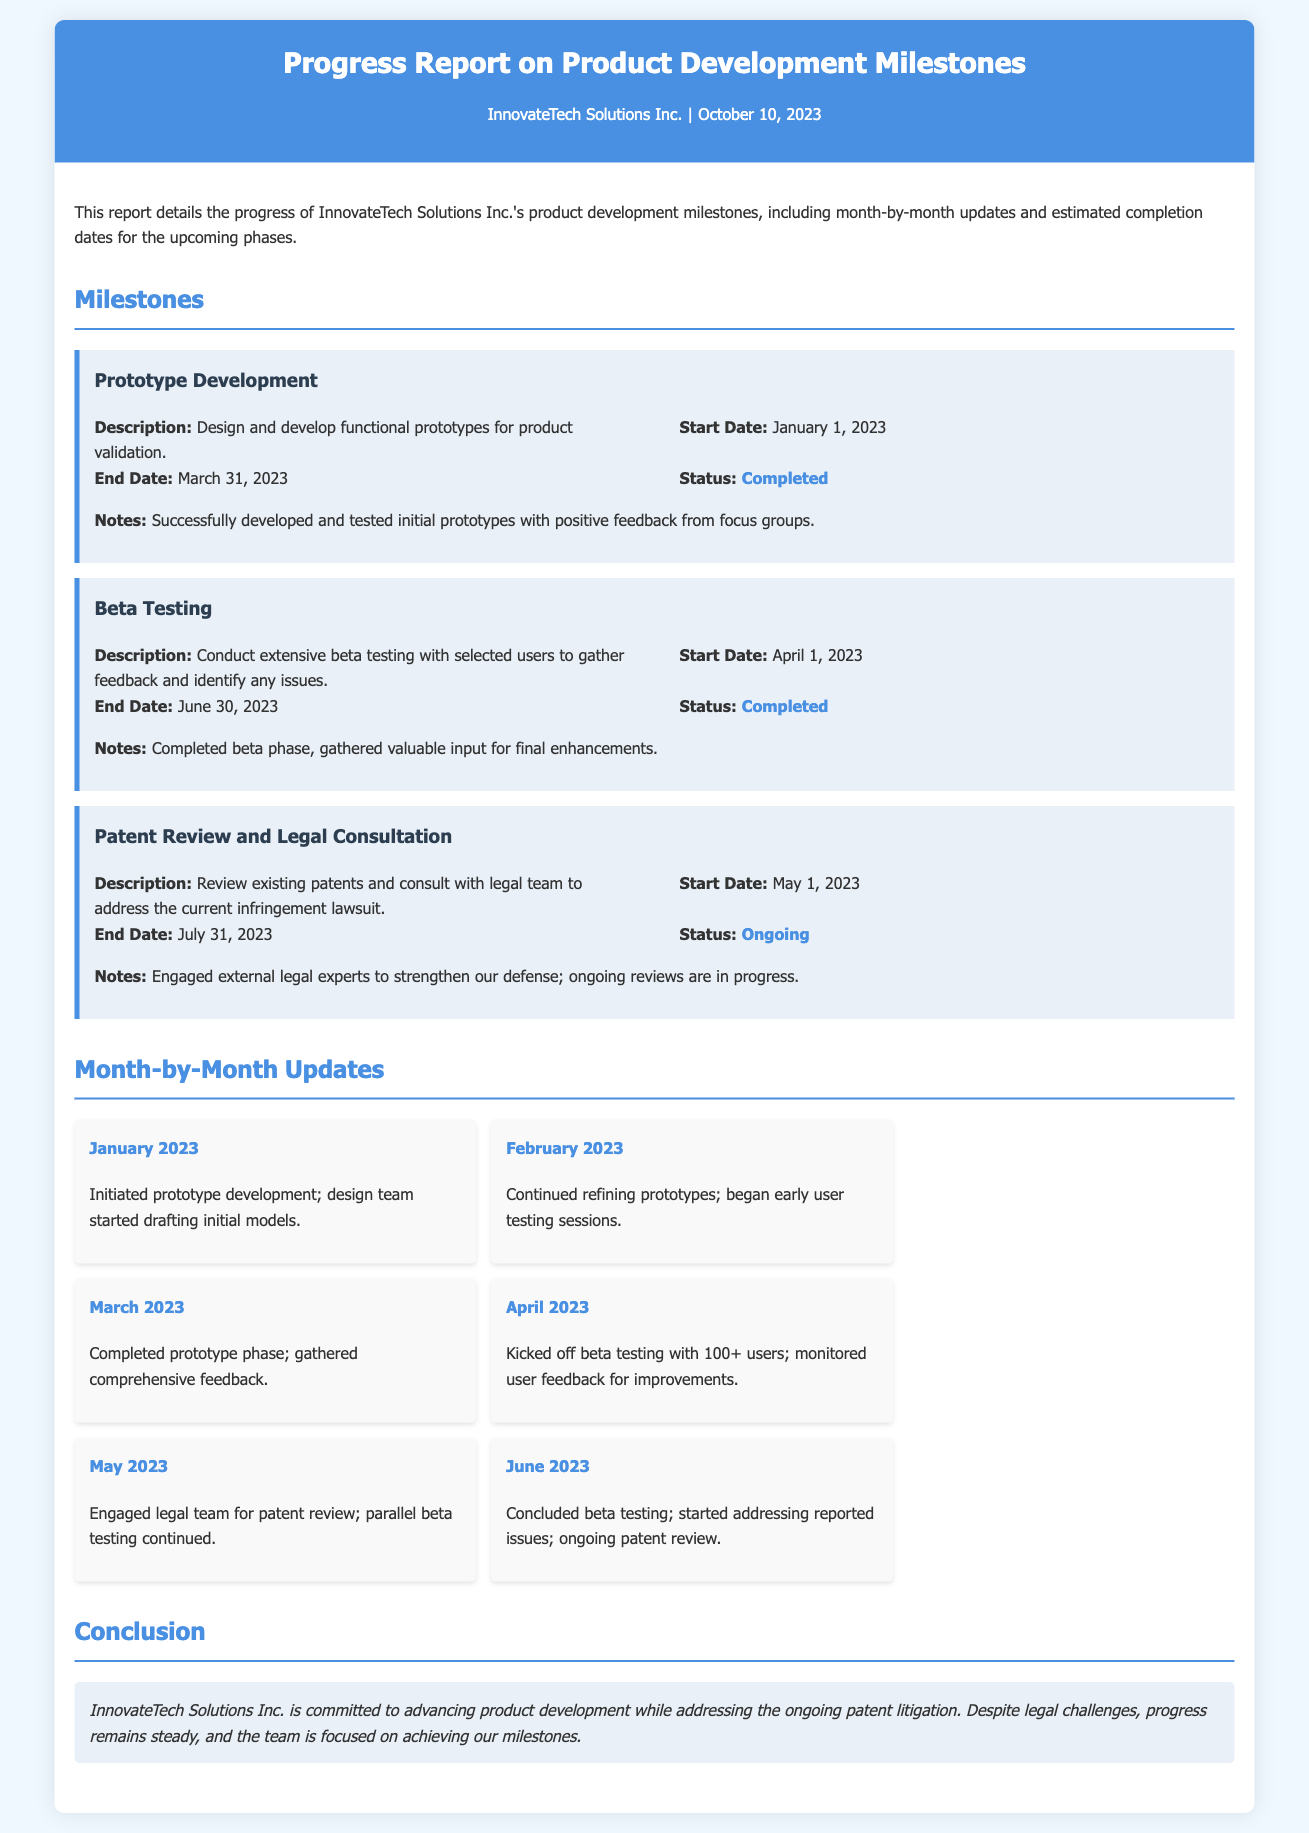What is the title of the report? The title of the report is clearly stated at the top of the document.
Answer: Progress Report on Product Development Milestones What was the start date for the Prototype Development milestone? The document specifies the start date for Prototype Development under the respective milestone.
Answer: January 1, 2023 What is the status of the Patent Review and Legal Consultation milestone? The document indicates the current status of each milestone, including Patent Review and Legal Consultation.
Answer: Ongoing How many users participated in the Beta Testing? The number of users for the Beta Testing phase is mentioned in the updates section.
Answer: 100+ Which month did the beta testing begin? The timeline for when beta testing commenced is detailed in the month-by-month updates.
Answer: April 2023 What was the main focus in June 2023? The month-by-month updates highlight the primary activities for June 2023.
Answer: Concluded beta testing What color is used for the header background? The design aspect of the document describes specific color choices in the header.
Answer: #4a90e2 What kind of experts were engaged during the ongoing patent review? The document includes information about the type of professionals involved in the patent review.
Answer: External legal experts 